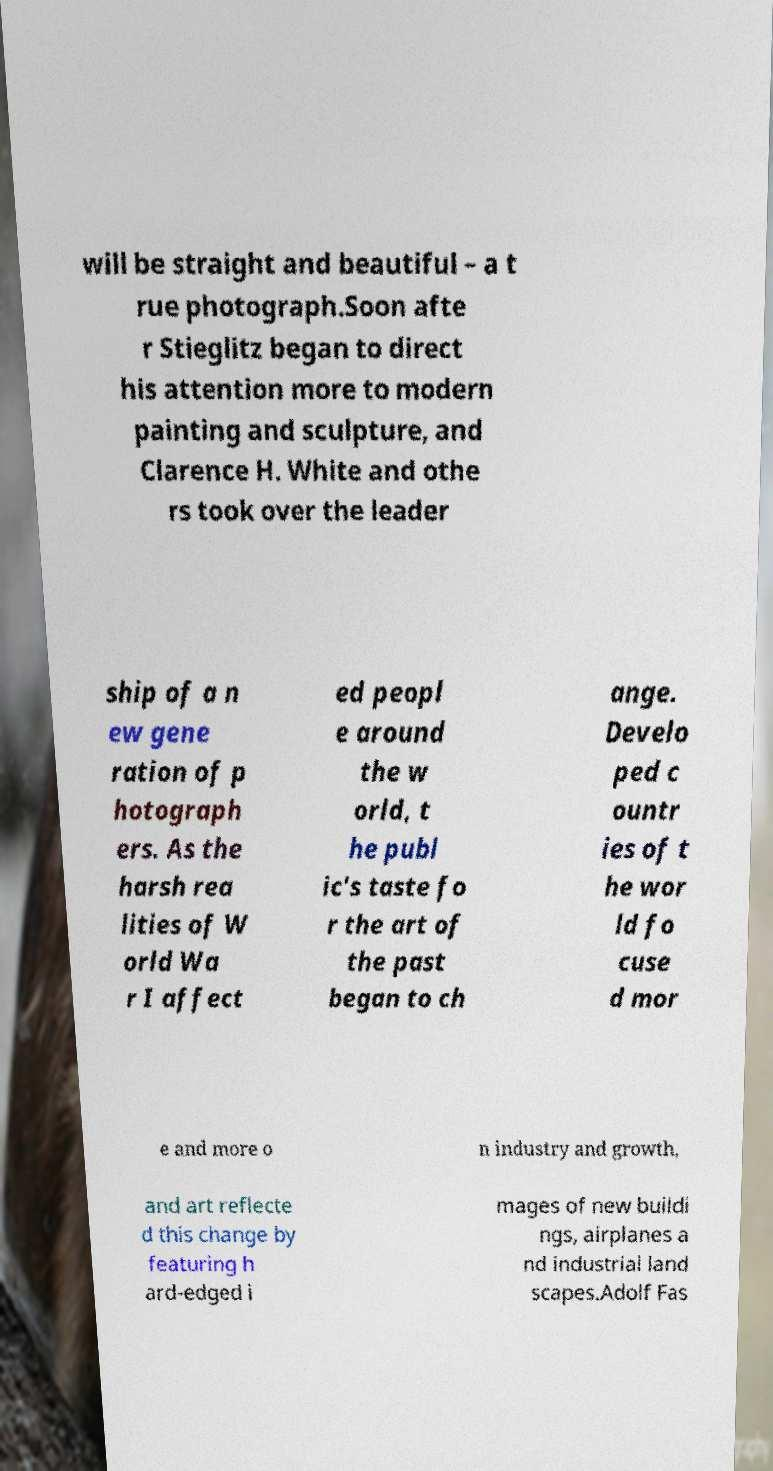For documentation purposes, I need the text within this image transcribed. Could you provide that? will be straight and beautiful – a t rue photograph.Soon afte r Stieglitz began to direct his attention more to modern painting and sculpture, and Clarence H. White and othe rs took over the leader ship of a n ew gene ration of p hotograph ers. As the harsh rea lities of W orld Wa r I affect ed peopl e around the w orld, t he publ ic's taste fo r the art of the past began to ch ange. Develo ped c ountr ies of t he wor ld fo cuse d mor e and more o n industry and growth, and art reflecte d this change by featuring h ard-edged i mages of new buildi ngs, airplanes a nd industrial land scapes.Adolf Fas 